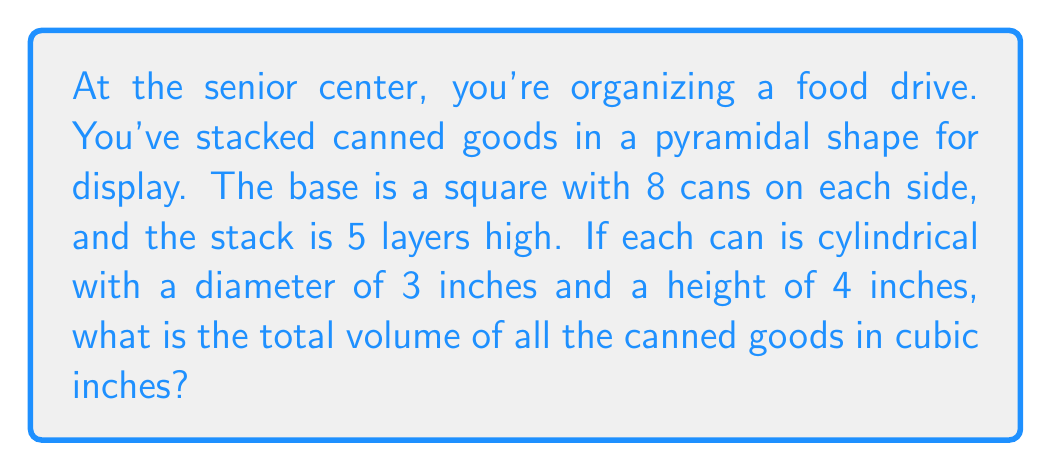Provide a solution to this math problem. Let's approach this step-by-step:

1) First, we need to calculate the number of cans in the pyramid:
   $$1^2 + 2^2 + 3^2 + 4^2 + 5^2 + 6^2 + 7^2 + 8^2 = 204$$

2) Now, we need to calculate the volume of a single can:
   Volume of a cylinder = $\pi r^2 h$
   Radius = 1.5 inches (half the diameter)
   Height = 4 inches
   $$V_{can} = \pi (1.5^2) (4) = 9\pi \approx 28.27 \text{ cubic inches}$$

3) The total volume is the number of cans multiplied by the volume of each can:
   $$V_{total} = 204 \times 9\pi = 1836\pi \text{ cubic inches}$$

4) Converting to a decimal:
   $$1836\pi \approx 5767.08 \text{ cubic inches}$$

[asy]
import three;

size(200);
currentprojection=perspective(6,3,2);

// Draw cans
for(int i=0; i<8; ++i)
  for(int j=0; j<8-i; ++j)
    for(int k=0; k<8-i; ++k)
      draw(shift((i+j)*1.5,(i+k)*1.5,i*2)*scale(0.75,0.75,2)*cylinder((0,0,0),(0,0,1),1),rgb(0.8,0.2,0.2));
[/asy]
Answer: $5767.08 \text{ cubic inches}$ 